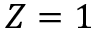Convert formula to latex. <formula><loc_0><loc_0><loc_500><loc_500>Z = 1</formula> 